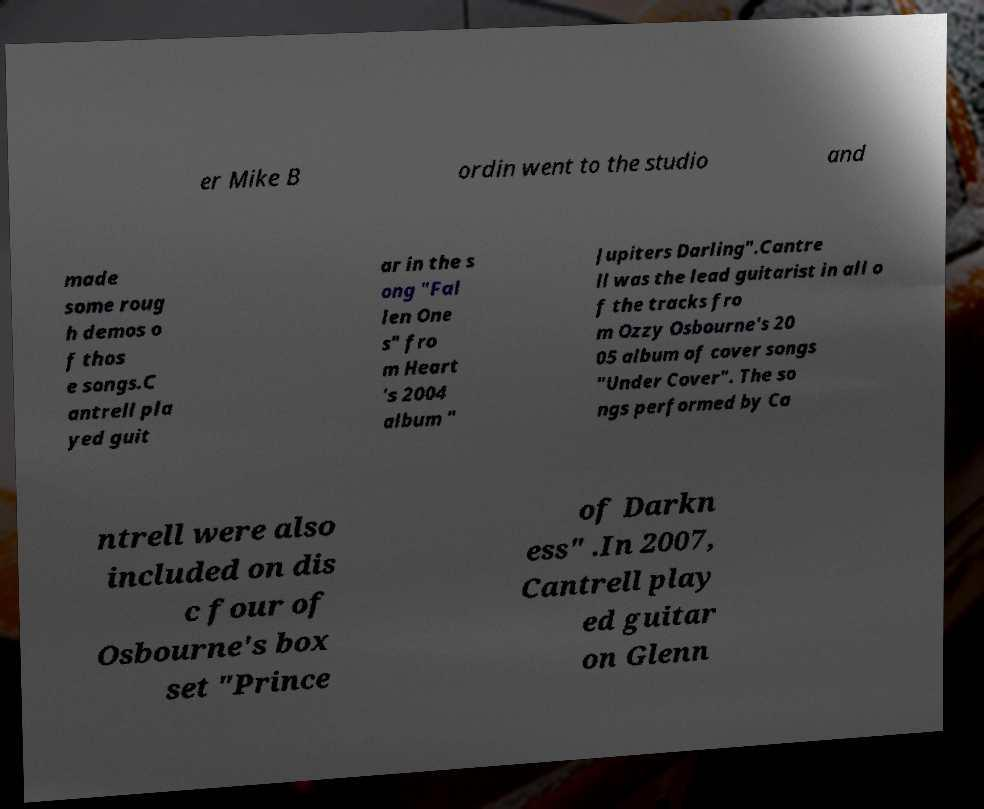What messages or text are displayed in this image? I need them in a readable, typed format. er Mike B ordin went to the studio and made some roug h demos o f thos e songs.C antrell pla yed guit ar in the s ong "Fal len One s" fro m Heart 's 2004 album " Jupiters Darling".Cantre ll was the lead guitarist in all o f the tracks fro m Ozzy Osbourne's 20 05 album of cover songs "Under Cover". The so ngs performed by Ca ntrell were also included on dis c four of Osbourne's box set "Prince of Darkn ess" .In 2007, Cantrell play ed guitar on Glenn 